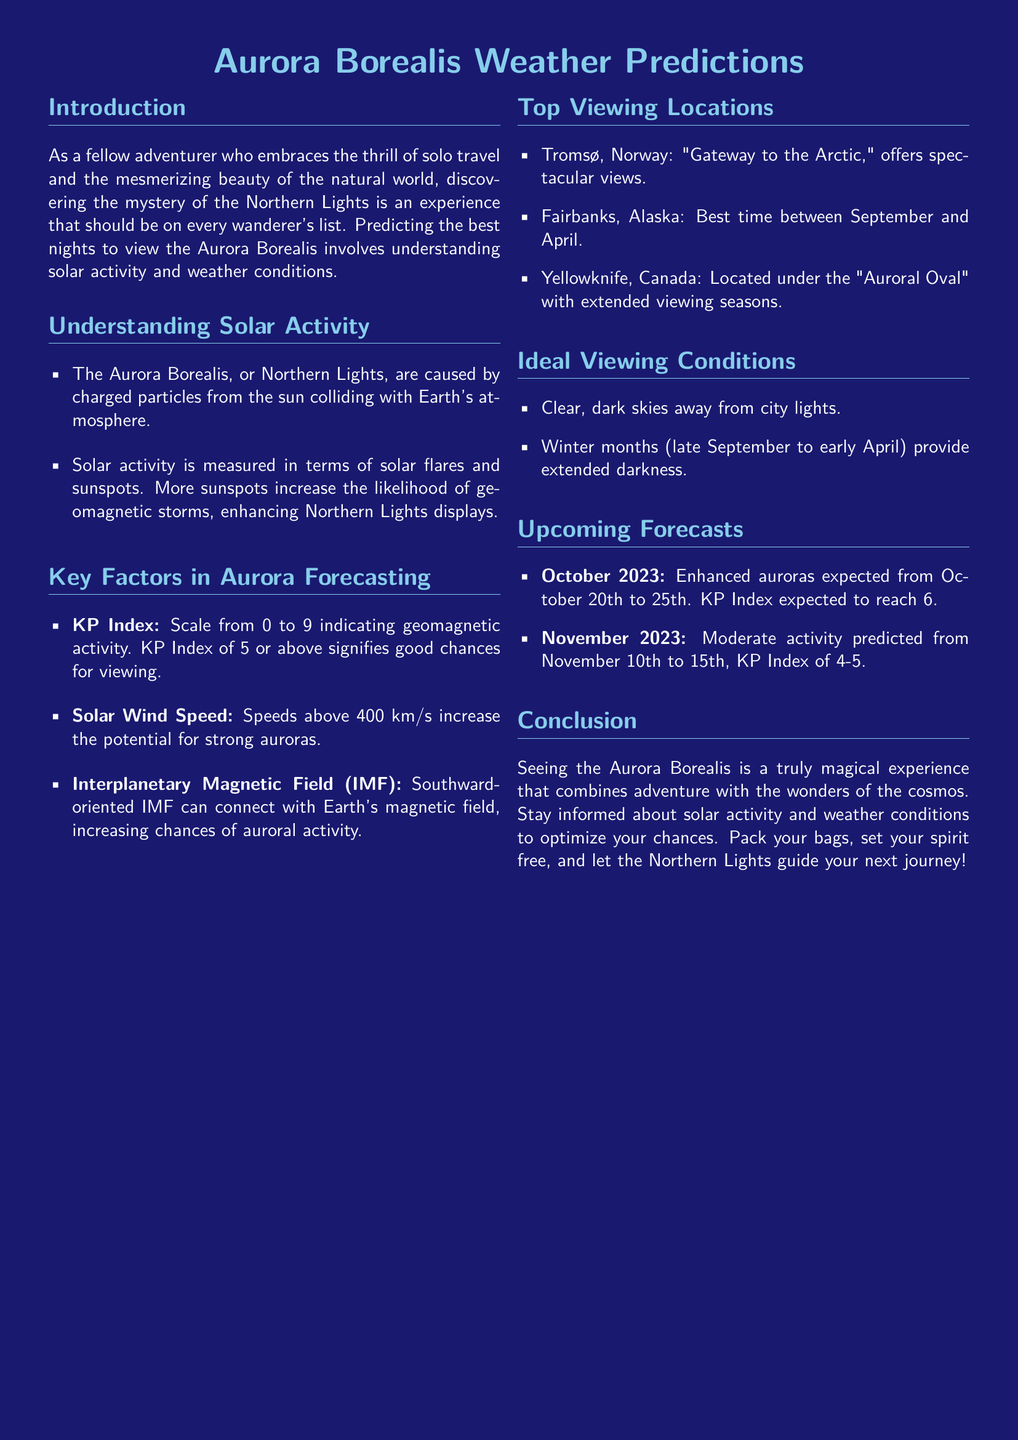What causes the Aurora Borealis? The Aurora Borealis is caused by charged particles from the sun colliding with Earth's atmosphere.
Answer: Charged particles from the sun What is the KP Index scale range? The KP Index is a scale used to indicate geomagnetic activity, ranging from 0 to 9.
Answer: 0 to 9 When is the best time to see Northern Lights in Fairbanks, Alaska? The document states that the best time to view in Fairbanks, Alaska is between September and April.
Answer: September to April What is the KP Index expected to reach during October 2023? The forecast indicates a KP Index expected to reach 6 during October 2023.
Answer: 6 What are ideal viewing conditions for the Northern Lights? Ideal viewing conditions include clear, dark skies away from city lights and winter months for extended darkness.
Answer: Clear, dark skies Which location is referred to as the "Gateway to the Arctic"? This location, known for its spectacular views of the Northern Lights, is Tromsø, Norway.
Answer: Tromsø, Norway What is the predicted KP Index for November 2023? The document predicts a KP Index of 4-5 for November 2023.
Answer: 4-5 Which month is mentioned for enhanced auroras in the upcoming forecasts? Enhanced auroras are expected in October 2023, specifically from October 20th to 25th.
Answer: October 2023 What is one critical factor that increases auroral activity? One critical factor that increases the chances of auroral activity is a southward-oriented Interplanetary Magnetic Field (IMF).
Answer: Southward-oriented IMF 